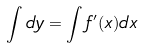Convert formula to latex. <formula><loc_0><loc_0><loc_500><loc_500>\int d y = \int f ^ { \prime } ( x ) d x</formula> 